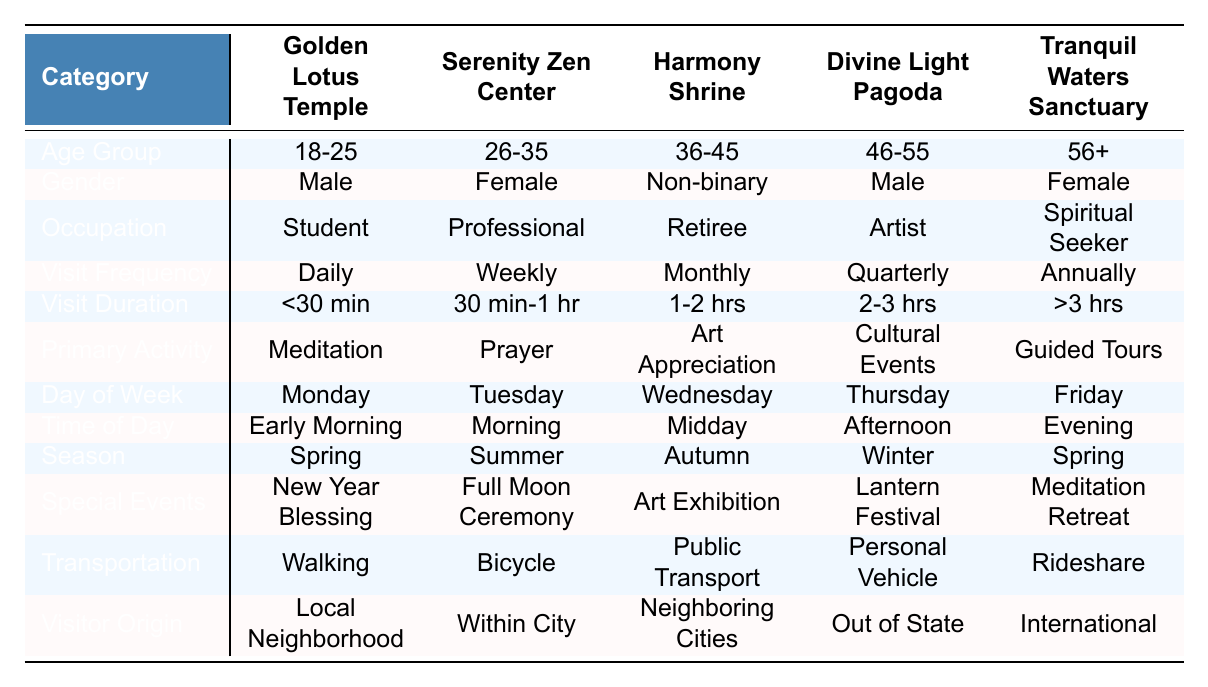What is the primary activity associated with the Divine Light Pagoda? The table indicates that the primary activity at the Divine Light Pagoda is Cultural Events.
Answer: Cultural Events Which temple has the highest visitor age group demographics? The visitor age groups are consistent across all temples (18-25, 26-35, 36-45, 46-55, 56+). Therefore, there is no single temple with a higher demographic.
Answer: None Is Art Appreciation a primary activity at any temple? The table shows that Art Appreciation is listed as the primary activity at the Harmony Shrine.
Answer: Yes, at Harmony Shrine What is the visit frequency of visitors to the Serenity Zen Center? According to the table, visitors to the Serenity Zen Center have a visit frequency of Weekly.
Answer: Weekly Considering the transportation modes, which temple has visitors using Public Transportation? The Divine Light Pagoda has listed Public Transportation as the mode of transport used by visitors.
Answer: Divine Light Pagoda Do more people visit the Golden Lotus Temple for Meditation than the Tranquil Waters Sanctuary for Guided Tours? The table shows that the Golden Lotus Temple's primary activity is Meditation, while the Tranquil Waters Sanctuary’s primary activity is Guided Tours. It cannot be determined directly from this data how many visitors choose each activity.
Answer: Cannot determine Which age group visits Tranquil Waters Sanctuary most frequently? The age group demographics are not explicitly stated for visit frequency across temples. However, the table indicates that the age groups are all present; thus a specific frequent age group is not identifiable in this context.
Answer: Not identifiable What is the primary activity on a Saturday at the Harmony Shrine? The table does not specify activities by days of the week, so we cannot determine the primary activity on Saturdays at the Harmony Shrine.
Answer: Not determinable Which temple has visitors that typically spend more than three hours during their visit? The visit duration at the table indicates that the Tranquil Waters Sanctuary allows for visits that may last more than three hours.
Answer: Tranquil Waters Sanctuary Are most visitors to the Golden Lotus Temple from the Local Neighborhood? The visitor origin details indicate that the local neighborhood is one of the origins but do not specify if it is the majority. Therefore, we cannot confirm this.
Answer: Cannot confirm 